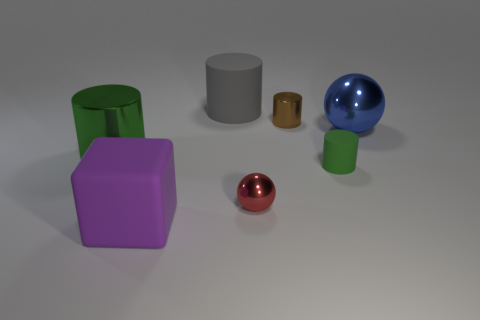Is the number of small green cylinders that are behind the purple thing greater than the number of brown matte cubes?
Make the answer very short. Yes. There is a big gray thing; is its shape the same as the small metal object that is behind the small red ball?
Your response must be concise. Yes. What number of balls have the same size as the green metal cylinder?
Ensure brevity in your answer.  1. There is a large rubber object that is in front of the green object on the right side of the purple rubber object; what number of cylinders are on the left side of it?
Provide a succinct answer. 1. Are there the same number of green metallic cylinders that are to the right of the green rubber cylinder and matte things that are to the left of the red metallic object?
Your answer should be compact. No. How many large green things are the same shape as the brown thing?
Your response must be concise. 1. Is there a small ball made of the same material as the brown object?
Your answer should be very brief. Yes. There is a large thing that is the same color as the small rubber cylinder; what shape is it?
Ensure brevity in your answer.  Cylinder. How many small green blocks are there?
Provide a succinct answer. 0. What number of blocks are brown things or big gray rubber things?
Your response must be concise. 0. 